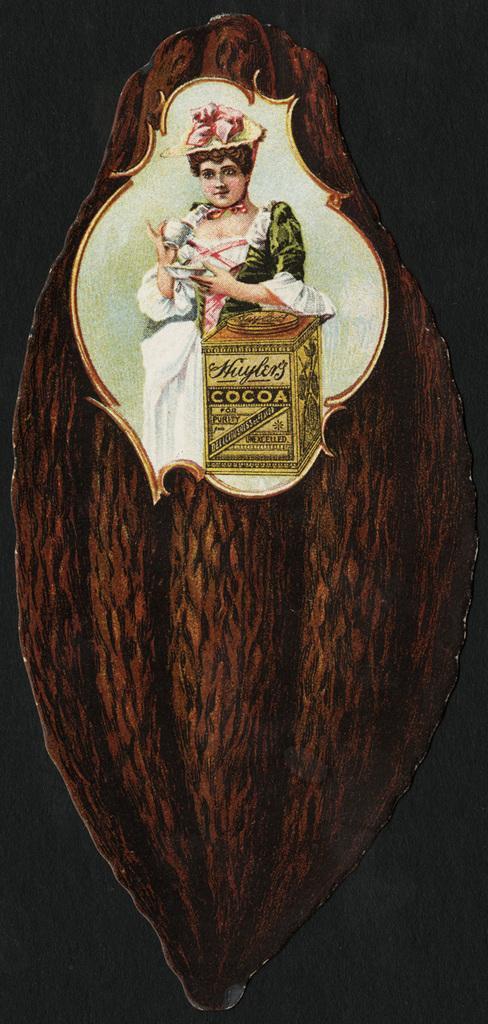Describe this image in one or two sentences. In this image, we can see a picture of a lady holding a cup and a saucer and we can see a box on the wood. 